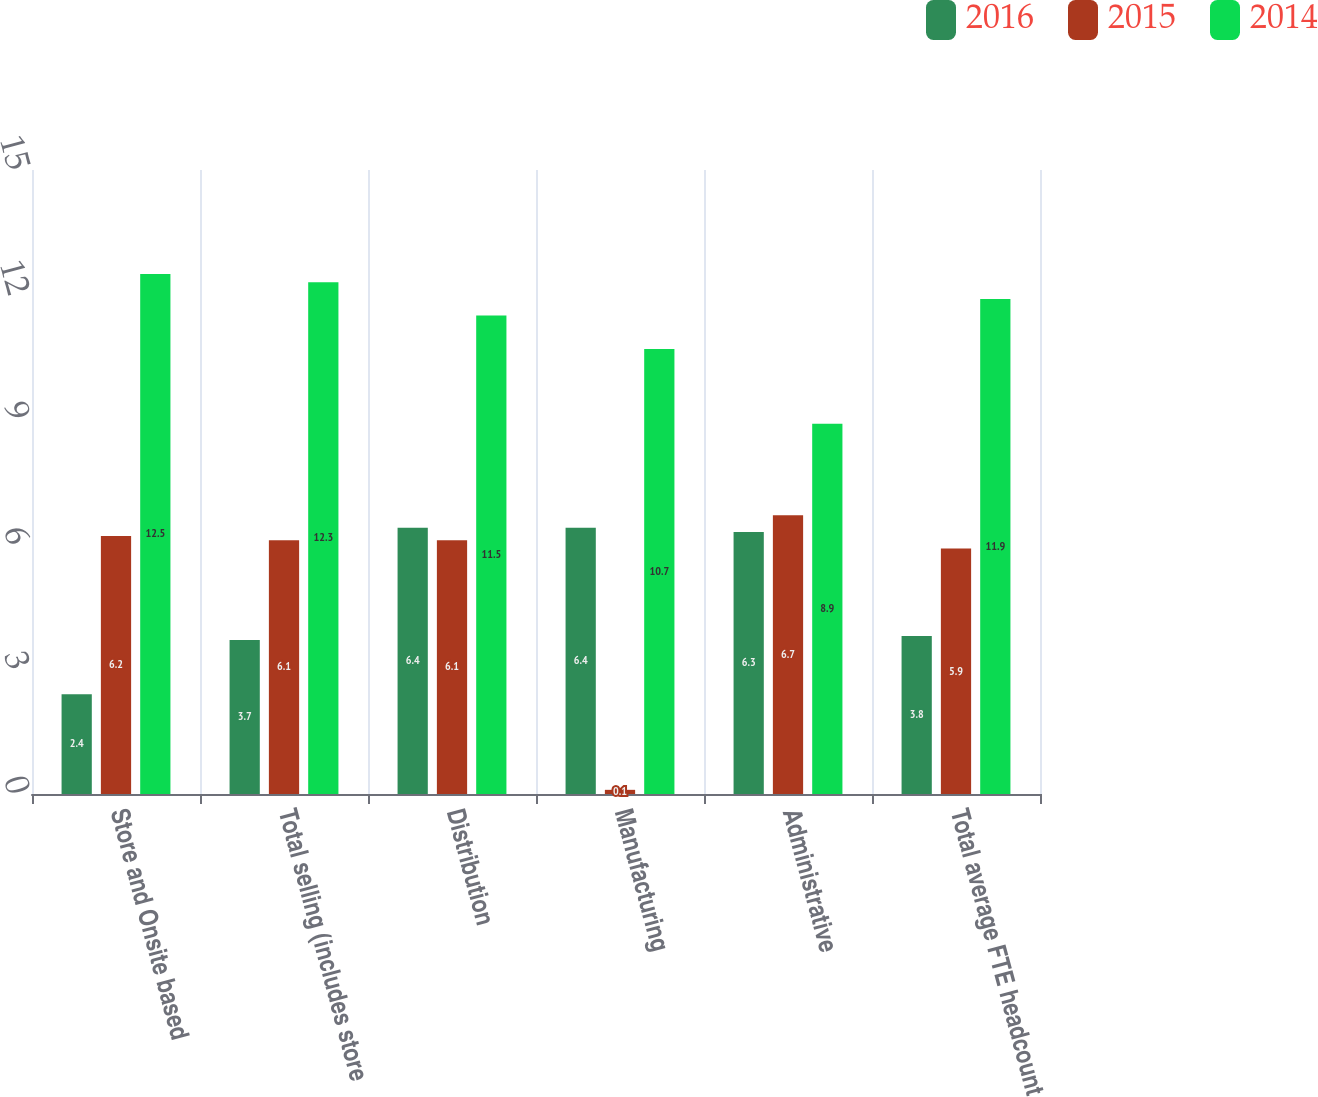<chart> <loc_0><loc_0><loc_500><loc_500><stacked_bar_chart><ecel><fcel>Store and Onsite based<fcel>Total selling (includes store<fcel>Distribution<fcel>Manufacturing<fcel>Administrative<fcel>Total average FTE headcount<nl><fcel>2016<fcel>2.4<fcel>3.7<fcel>6.4<fcel>6.4<fcel>6.3<fcel>3.8<nl><fcel>2015<fcel>6.2<fcel>6.1<fcel>6.1<fcel>0.1<fcel>6.7<fcel>5.9<nl><fcel>2014<fcel>12.5<fcel>12.3<fcel>11.5<fcel>10.7<fcel>8.9<fcel>11.9<nl></chart> 